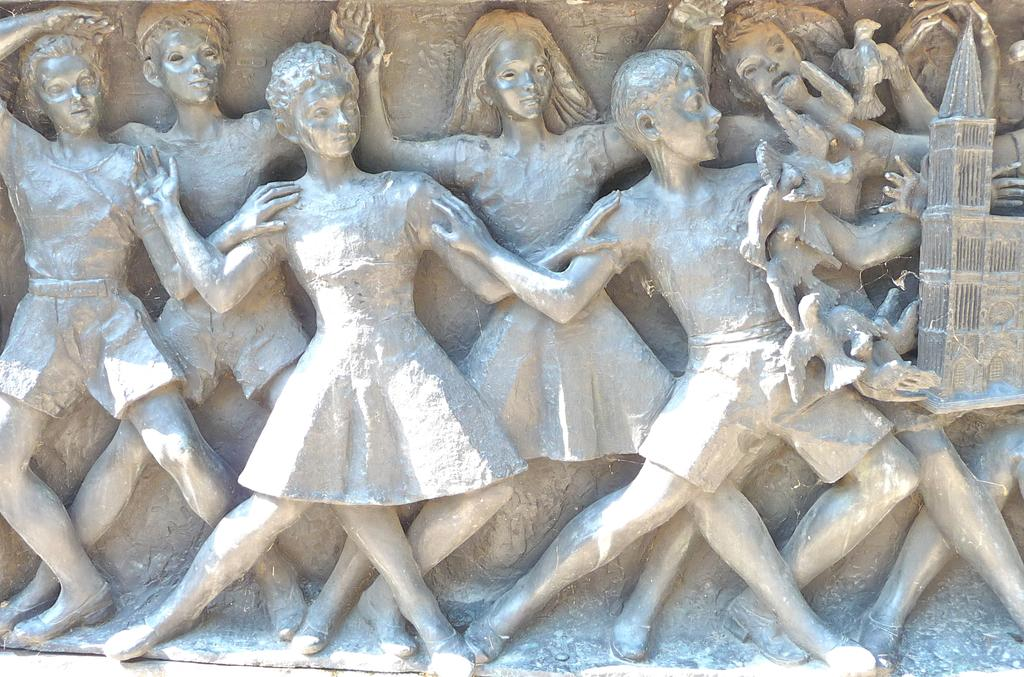What type of art is depicted in the image? There are sculptures in the image. What type of railway is visible in the image? There is no railway present in the image; it only features sculptures. What type of wax is used to create the sculptures in the image? The provided facts do not mention the materials used to create the sculptures, so we cannot determine if wax is used. 